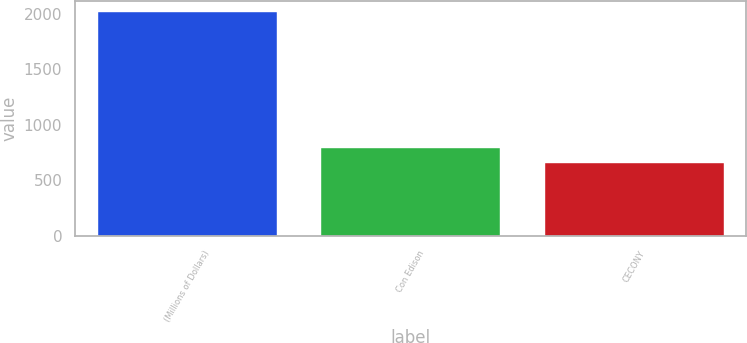Convert chart to OTSL. <chart><loc_0><loc_0><loc_500><loc_500><bar_chart><fcel>(Millions of Dollars)<fcel>Con Edison<fcel>CECONY<nl><fcel>2017<fcel>789.4<fcel>653<nl></chart> 